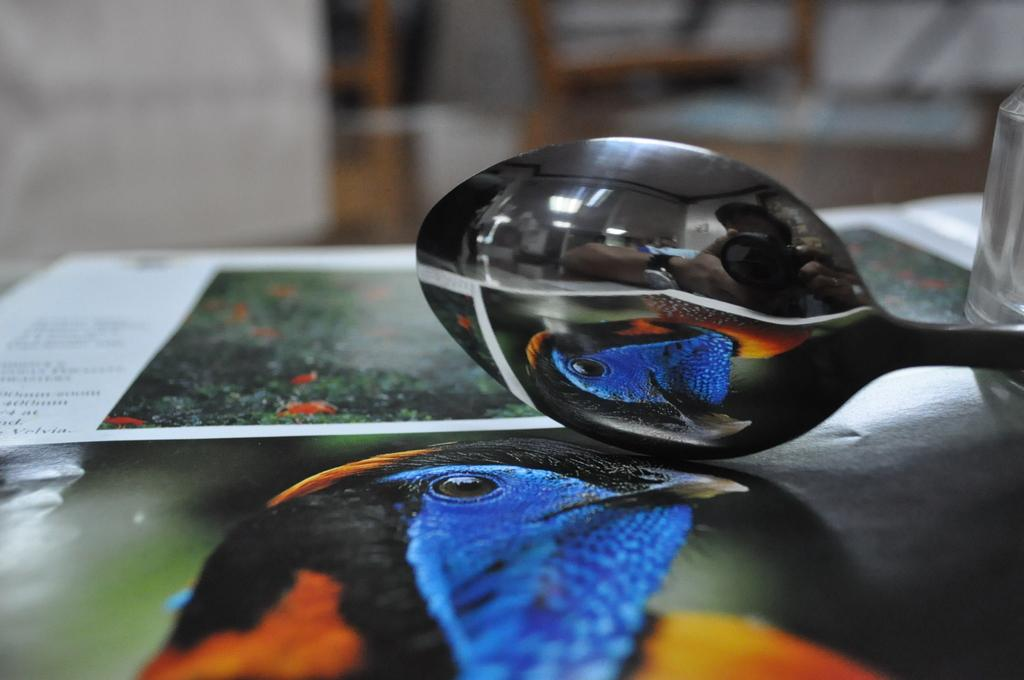What utensil is visible in the image? There is a spoon in the image. What type of container is present in the image? There is a glass in the image. What objects are on the table in the image? There are posters on a table in the image. What type of quartz is used as a decoration on the table in the image? There is no quartz present in the image; it only features a spoon, a glass, and posters on a table. How does the wrench help in the process of creating the posters in the image? There is no wrench present in the image, and the posters do not require any tools for their creation or display. 